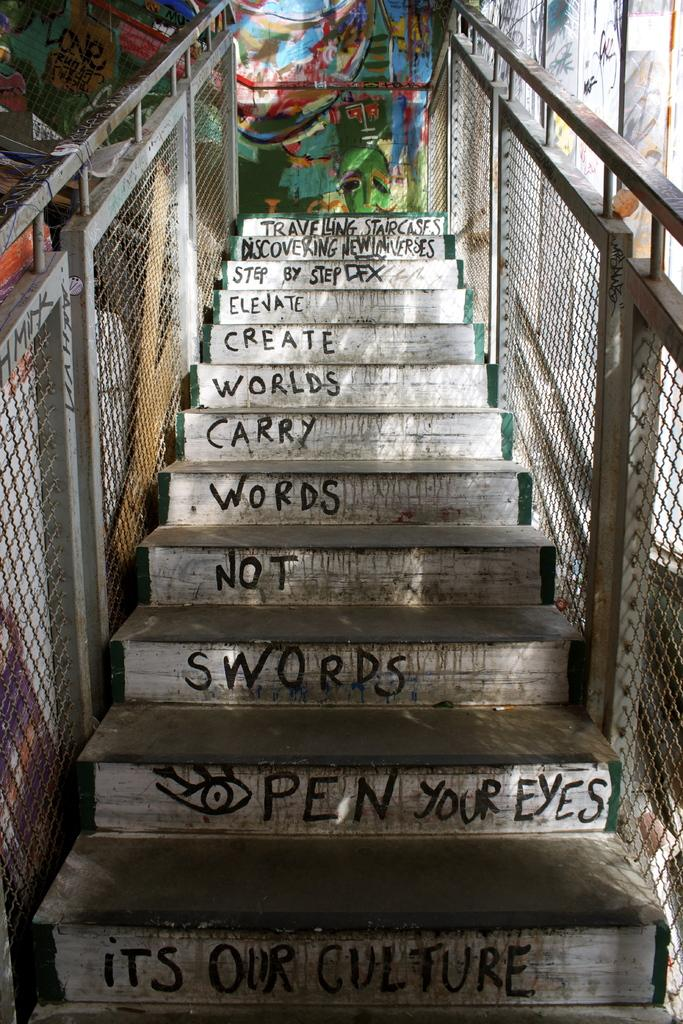What structure is present in the image? There is a staircase in the image. What is written or depicted on the staircase? The staircase has text on it. What type of railings are present on the staircase? There are metal railings on both sides of the staircase. What can be seen in the background of the image? There is a wall in the background of the image. What is featured on the wall in the image? The wall has a painting on it. What type of pickle is being served in the office by the secretary in the image? There is no pickle, office, or secretary present in the image; it features a staircase with text, metal railings, a wall, and a painting. 